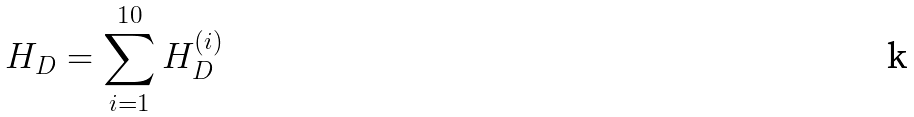Convert formula to latex. <formula><loc_0><loc_0><loc_500><loc_500>H _ { D } = \sum _ { i = 1 } ^ { 1 0 } H _ { D } ^ { ( i ) }</formula> 